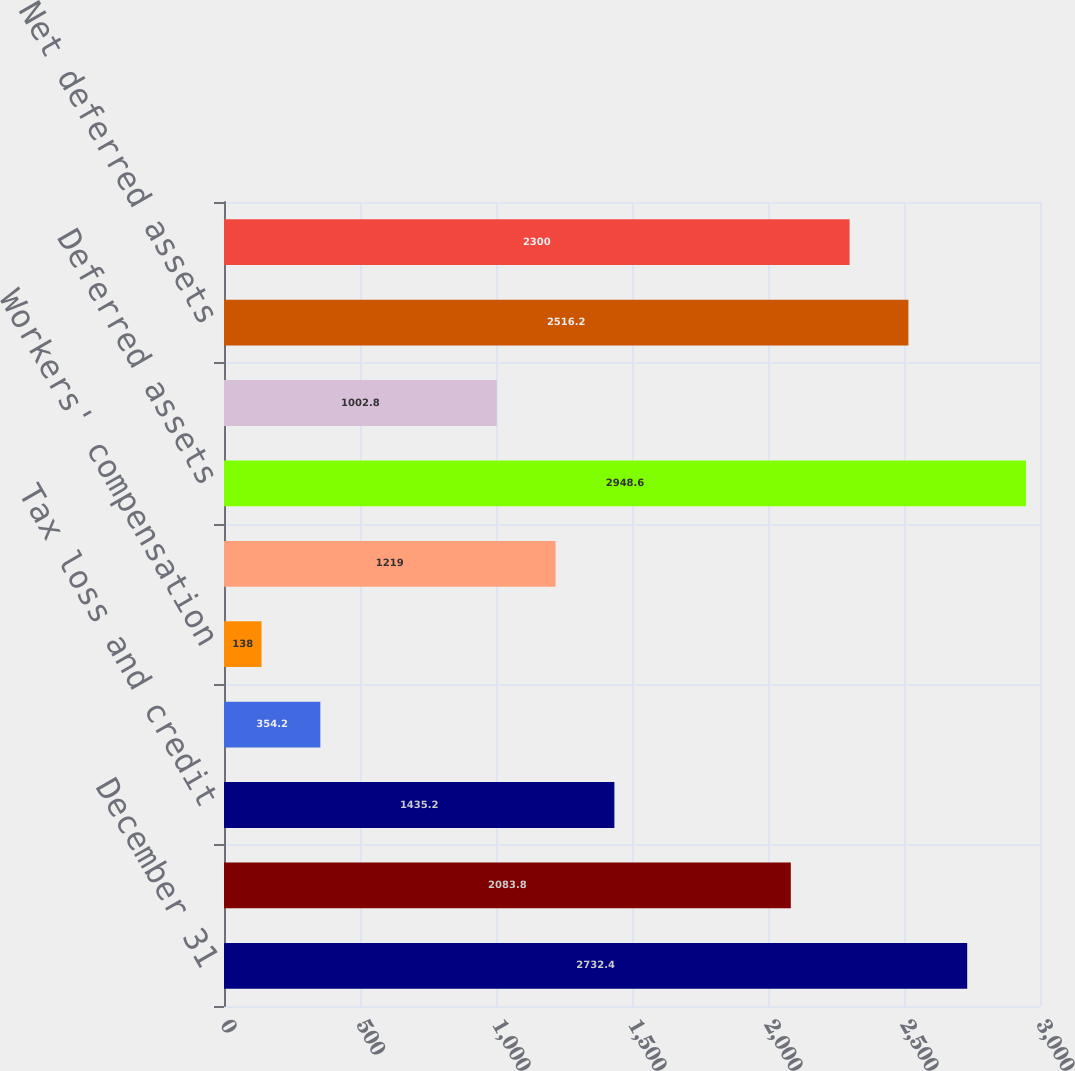Convert chart to OTSL. <chart><loc_0><loc_0><loc_500><loc_500><bar_chart><fcel>December 31<fcel>Retirement benefits<fcel>Tax loss and credit<fcel>Salaries and wages<fcel>Workers' compensation<fcel>Other<fcel>Deferred assets<fcel>Valuation allowances<fcel>Net deferred assets<fcel>Intangible assets<nl><fcel>2732.4<fcel>2083.8<fcel>1435.2<fcel>354.2<fcel>138<fcel>1219<fcel>2948.6<fcel>1002.8<fcel>2516.2<fcel>2300<nl></chart> 